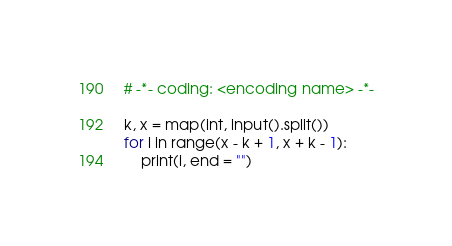Convert code to text. <code><loc_0><loc_0><loc_500><loc_500><_Python_># -*- coding: <encoding name> -*-

k, x = map(int, input().split())
for i in range(x - k + 1, x + k - 1):
	print(i, end = "")</code> 